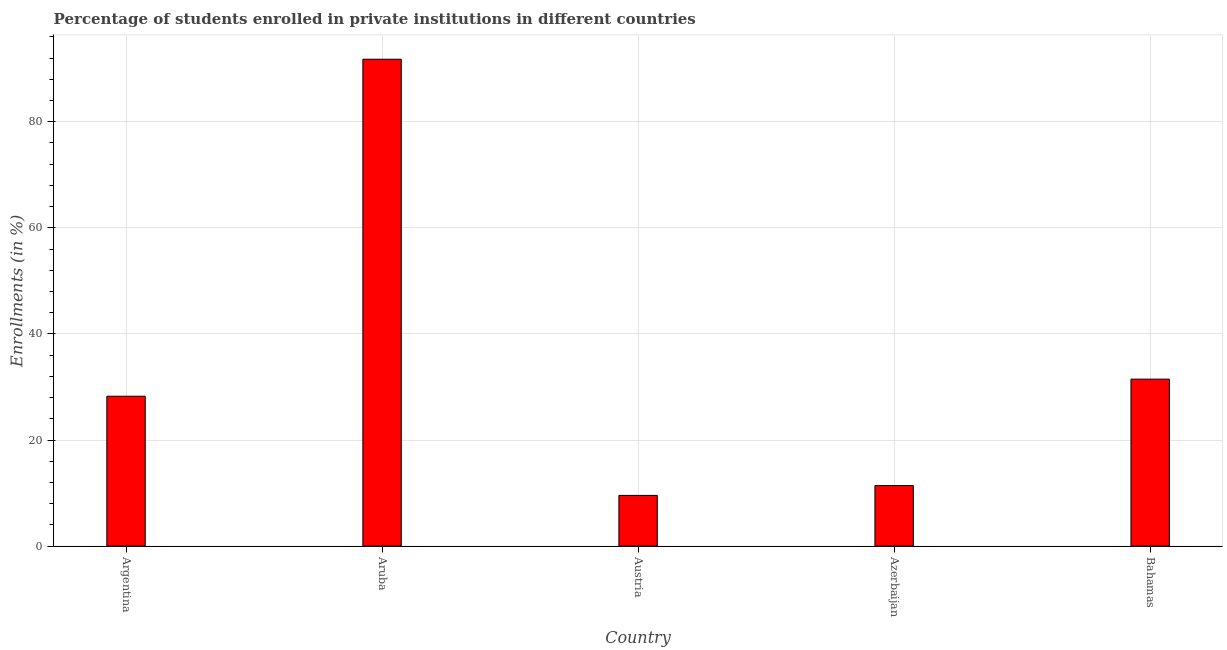Does the graph contain any zero values?
Offer a terse response. No. Does the graph contain grids?
Provide a succinct answer. Yes. What is the title of the graph?
Keep it short and to the point. Percentage of students enrolled in private institutions in different countries. What is the label or title of the Y-axis?
Keep it short and to the point. Enrollments (in %). What is the enrollments in private institutions in Azerbaijan?
Provide a succinct answer. 11.41. Across all countries, what is the maximum enrollments in private institutions?
Offer a very short reply. 91.79. Across all countries, what is the minimum enrollments in private institutions?
Ensure brevity in your answer.  9.56. In which country was the enrollments in private institutions maximum?
Make the answer very short. Aruba. What is the sum of the enrollments in private institutions?
Provide a succinct answer. 172.49. What is the difference between the enrollments in private institutions in Argentina and Austria?
Provide a succinct answer. 18.7. What is the average enrollments in private institutions per country?
Make the answer very short. 34.5. What is the median enrollments in private institutions?
Keep it short and to the point. 28.26. In how many countries, is the enrollments in private institutions greater than 64 %?
Your answer should be compact. 1. What is the ratio of the enrollments in private institutions in Aruba to that in Austria?
Ensure brevity in your answer.  9.6. Is the difference between the enrollments in private institutions in Aruba and Austria greater than the difference between any two countries?
Keep it short and to the point. Yes. What is the difference between the highest and the second highest enrollments in private institutions?
Offer a very short reply. 60.31. What is the difference between the highest and the lowest enrollments in private institutions?
Your response must be concise. 82.23. Are all the bars in the graph horizontal?
Offer a very short reply. No. How many countries are there in the graph?
Give a very brief answer. 5. What is the difference between two consecutive major ticks on the Y-axis?
Provide a short and direct response. 20. What is the Enrollments (in %) in Argentina?
Ensure brevity in your answer.  28.26. What is the Enrollments (in %) of Aruba?
Your answer should be very brief. 91.79. What is the Enrollments (in %) of Austria?
Your answer should be compact. 9.56. What is the Enrollments (in %) in Azerbaijan?
Give a very brief answer. 11.41. What is the Enrollments (in %) of Bahamas?
Offer a terse response. 31.48. What is the difference between the Enrollments (in %) in Argentina and Aruba?
Make the answer very short. -63.53. What is the difference between the Enrollments (in %) in Argentina and Austria?
Make the answer very short. 18.7. What is the difference between the Enrollments (in %) in Argentina and Azerbaijan?
Give a very brief answer. 16.84. What is the difference between the Enrollments (in %) in Argentina and Bahamas?
Offer a terse response. -3.22. What is the difference between the Enrollments (in %) in Aruba and Austria?
Make the answer very short. 82.23. What is the difference between the Enrollments (in %) in Aruba and Azerbaijan?
Keep it short and to the point. 80.37. What is the difference between the Enrollments (in %) in Aruba and Bahamas?
Your response must be concise. 60.31. What is the difference between the Enrollments (in %) in Austria and Azerbaijan?
Ensure brevity in your answer.  -1.86. What is the difference between the Enrollments (in %) in Austria and Bahamas?
Provide a short and direct response. -21.92. What is the difference between the Enrollments (in %) in Azerbaijan and Bahamas?
Provide a succinct answer. -20.06. What is the ratio of the Enrollments (in %) in Argentina to that in Aruba?
Give a very brief answer. 0.31. What is the ratio of the Enrollments (in %) in Argentina to that in Austria?
Give a very brief answer. 2.96. What is the ratio of the Enrollments (in %) in Argentina to that in Azerbaijan?
Your answer should be compact. 2.48. What is the ratio of the Enrollments (in %) in Argentina to that in Bahamas?
Ensure brevity in your answer.  0.9. What is the ratio of the Enrollments (in %) in Aruba to that in Austria?
Your response must be concise. 9.6. What is the ratio of the Enrollments (in %) in Aruba to that in Azerbaijan?
Offer a terse response. 8.04. What is the ratio of the Enrollments (in %) in Aruba to that in Bahamas?
Make the answer very short. 2.92. What is the ratio of the Enrollments (in %) in Austria to that in Azerbaijan?
Your answer should be compact. 0.84. What is the ratio of the Enrollments (in %) in Austria to that in Bahamas?
Provide a succinct answer. 0.3. What is the ratio of the Enrollments (in %) in Azerbaijan to that in Bahamas?
Make the answer very short. 0.36. 